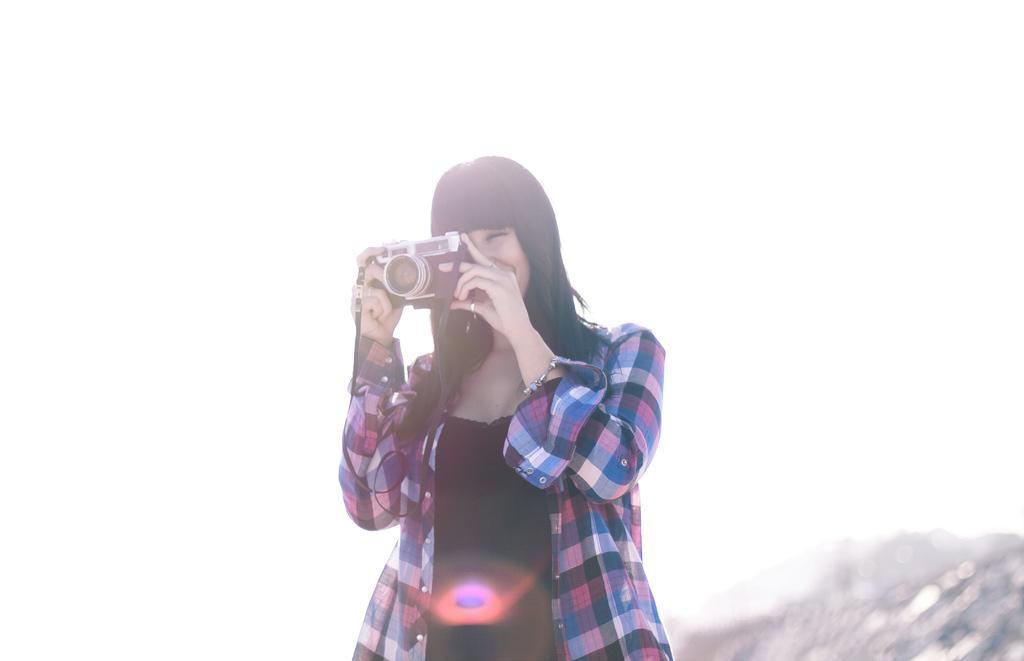Who is the main subject in the image? There is a woman in the image. What is the woman holding in the image? The woman is holding a camera. Can you describe any objects visible at the bottom of the image? Unfortunately, the provided facts do not mention any objects visible at the bottom of the image. What type of voyage is the woman embarking on in the image? There is no indication of a voyage in the image; the woman is simply holding a camera. 